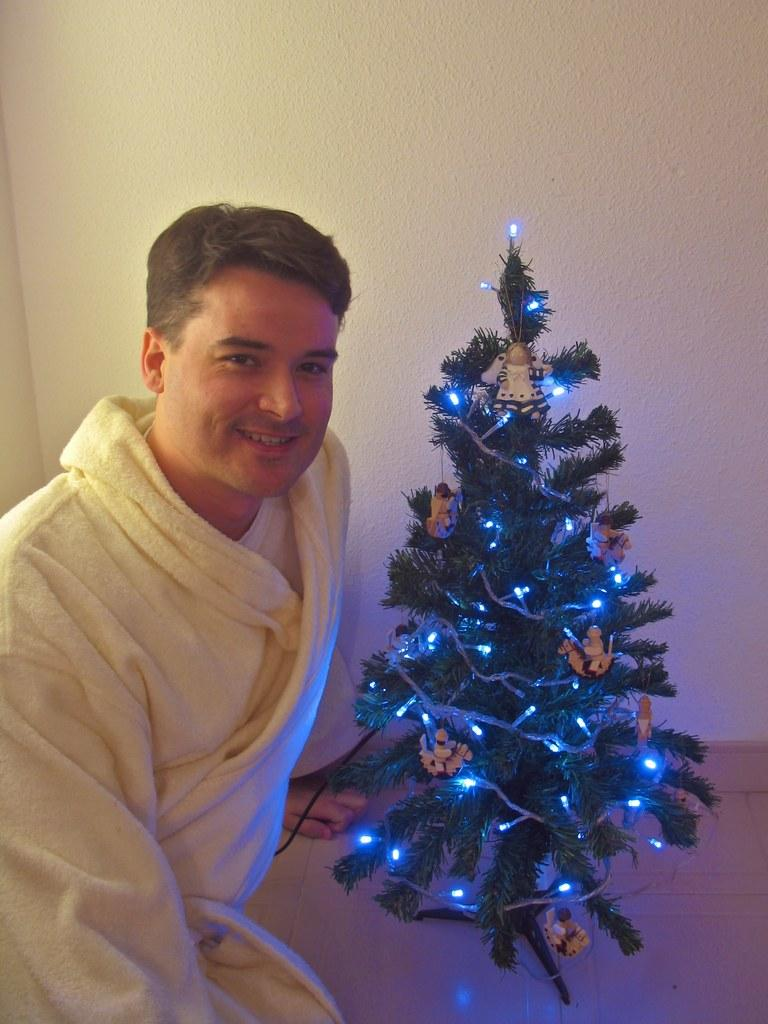What is the person in the image doing? The person is sitting on the floor in the image. What is the person's facial expression? The person is smiling. What can be seen in the background of the image? There is a wall in the background of the image. What is the main decoration in the image? There is a Christmas tree with decorative lights in the image. What other objects are associated with the Christmas tree? There are objects associated with the Christmas tree, but the specific items are not mentioned in the facts. What type of kettle is being used to exchange gifts in the image? There is no kettle or gift exchange present in the image; it features a person sitting on the floor and a Christmas tree with decorative lights. 